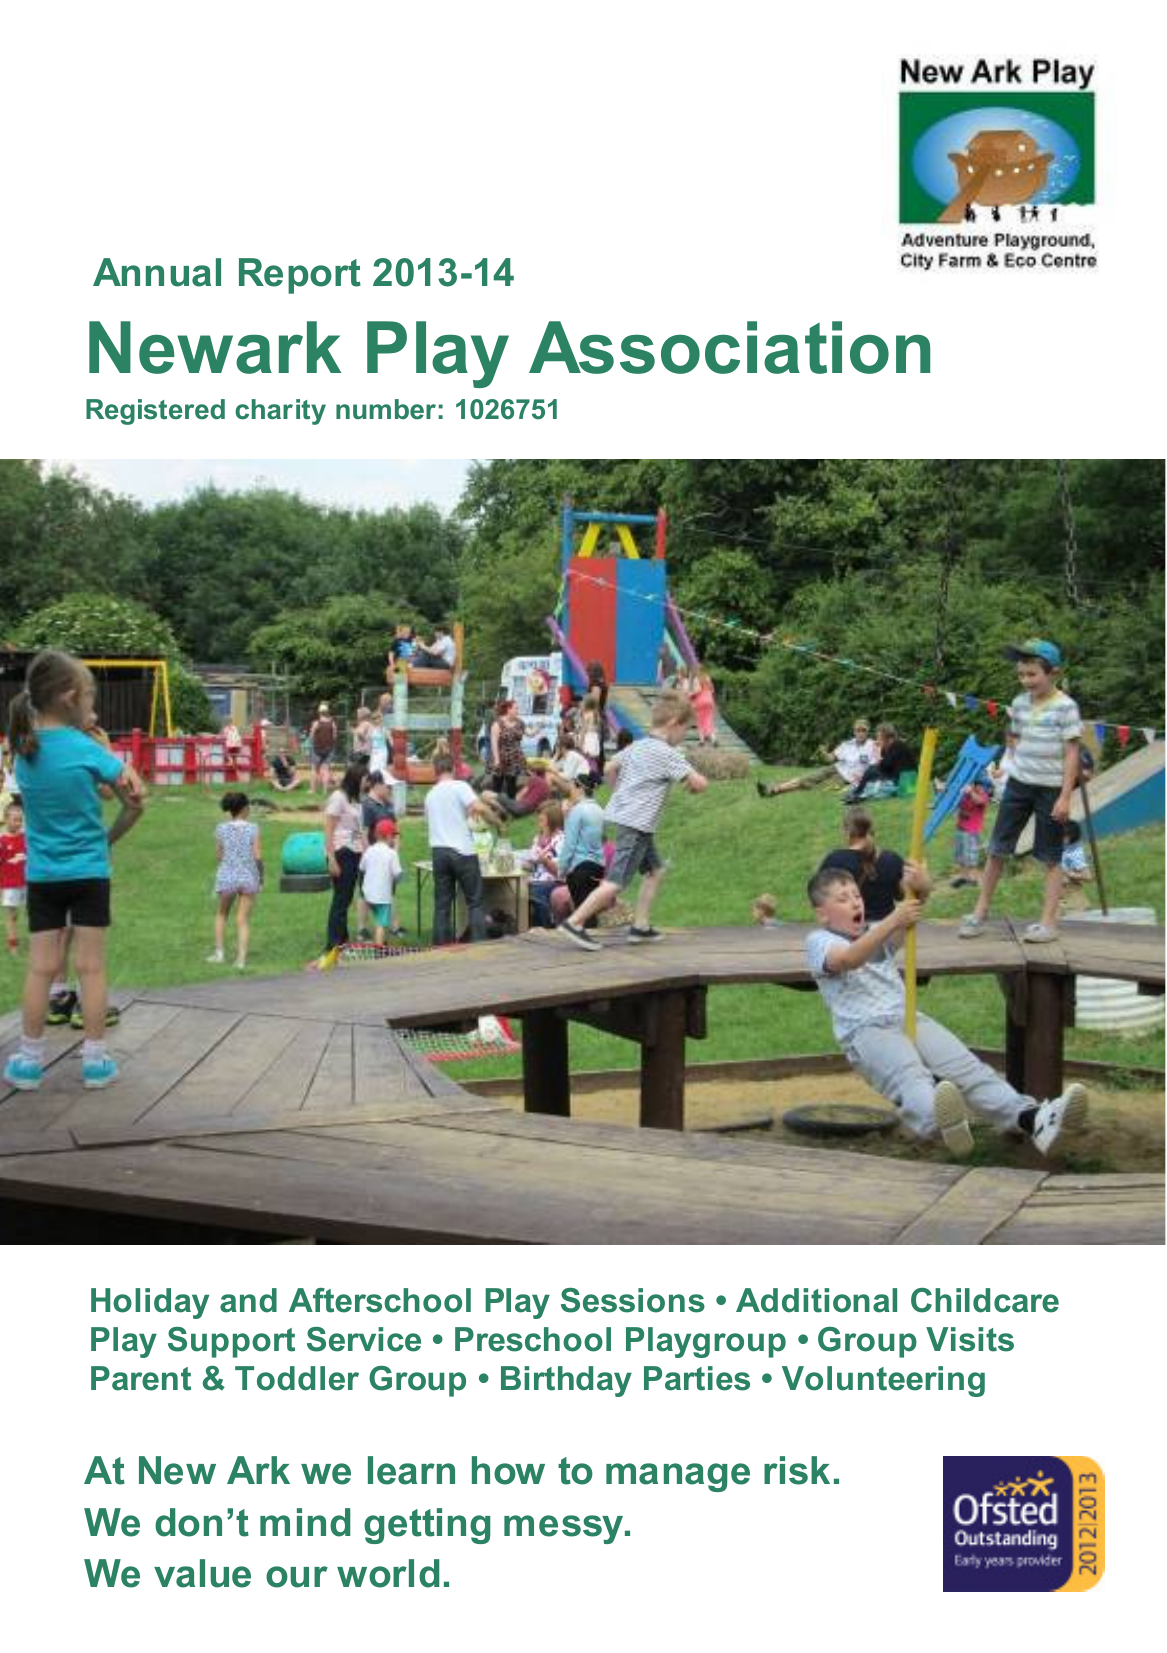What is the value for the charity_number?
Answer the question using a single word or phrase. 1026751 